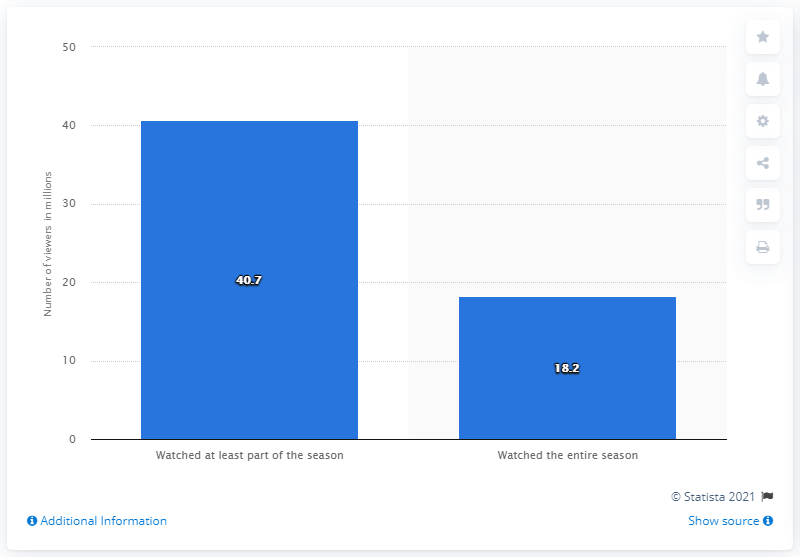Point out several critical features in this image. Approximately 18.2 people watched the entire season of Stranger Things in the first four days of its release. The number of Netflix members who streamed Stranger Things episodes within the first four days of the season's release was 40,700. 